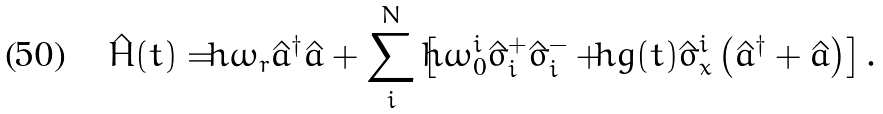Convert formula to latex. <formula><loc_0><loc_0><loc_500><loc_500>\hat { H } ( t ) = \hbar { \omega } _ { r } \hat { a } ^ { \dagger } \hat { a } + \sum _ { i } ^ { N } \left [ \hbar { \omega } _ { 0 } ^ { i } \hat { \sigma } ^ { + } _ { i } \hat { \sigma } ^ { - } _ { i } + \hbar { g } ( t ) \hat { \sigma } _ { x } ^ { i } \left ( \hat { a } ^ { \dagger } + \hat { a } \right ) \right ] .</formula> 